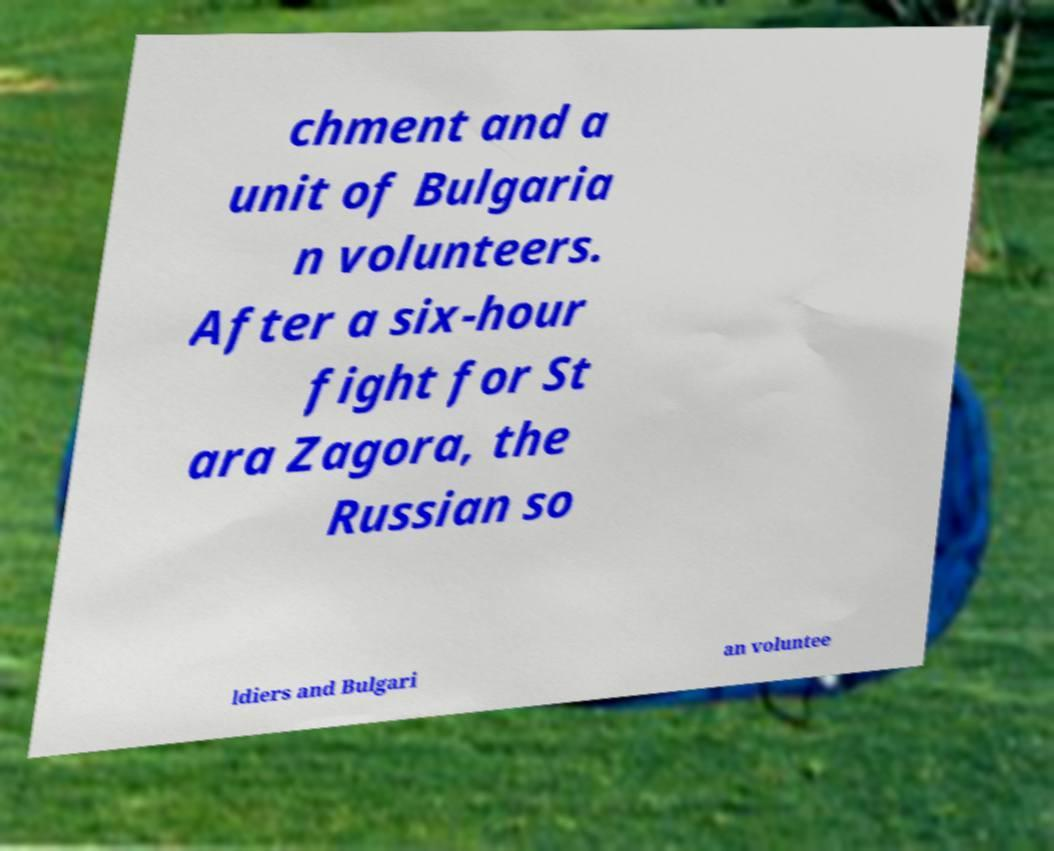Please read and relay the text visible in this image. What does it say? chment and a unit of Bulgaria n volunteers. After a six-hour fight for St ara Zagora, the Russian so ldiers and Bulgari an voluntee 